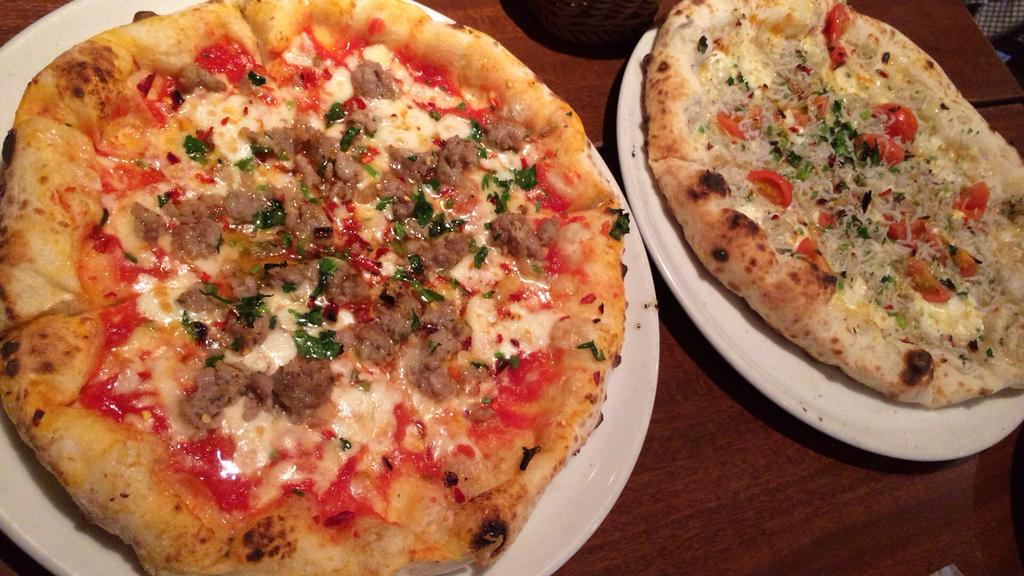How many plates are visible in the image? There are 2 white plates in the image. What is on the plates? There are pizzas on the plates. What is the color of the surface the plates are on? The plates are on a brown color surface. Can you describe the unspecified "thing" in the image? Unfortunately, the provided facts do not give any information about the unspecified "thing" in the image. How many trees can be seen growing out of the pizzas in the image? There are no trees present in the image, let alone growing out of the pizzas. 